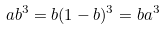Convert formula to latex. <formula><loc_0><loc_0><loc_500><loc_500>a b ^ { 3 } = b ( 1 - b ) ^ { 3 } = b a ^ { 3 }</formula> 